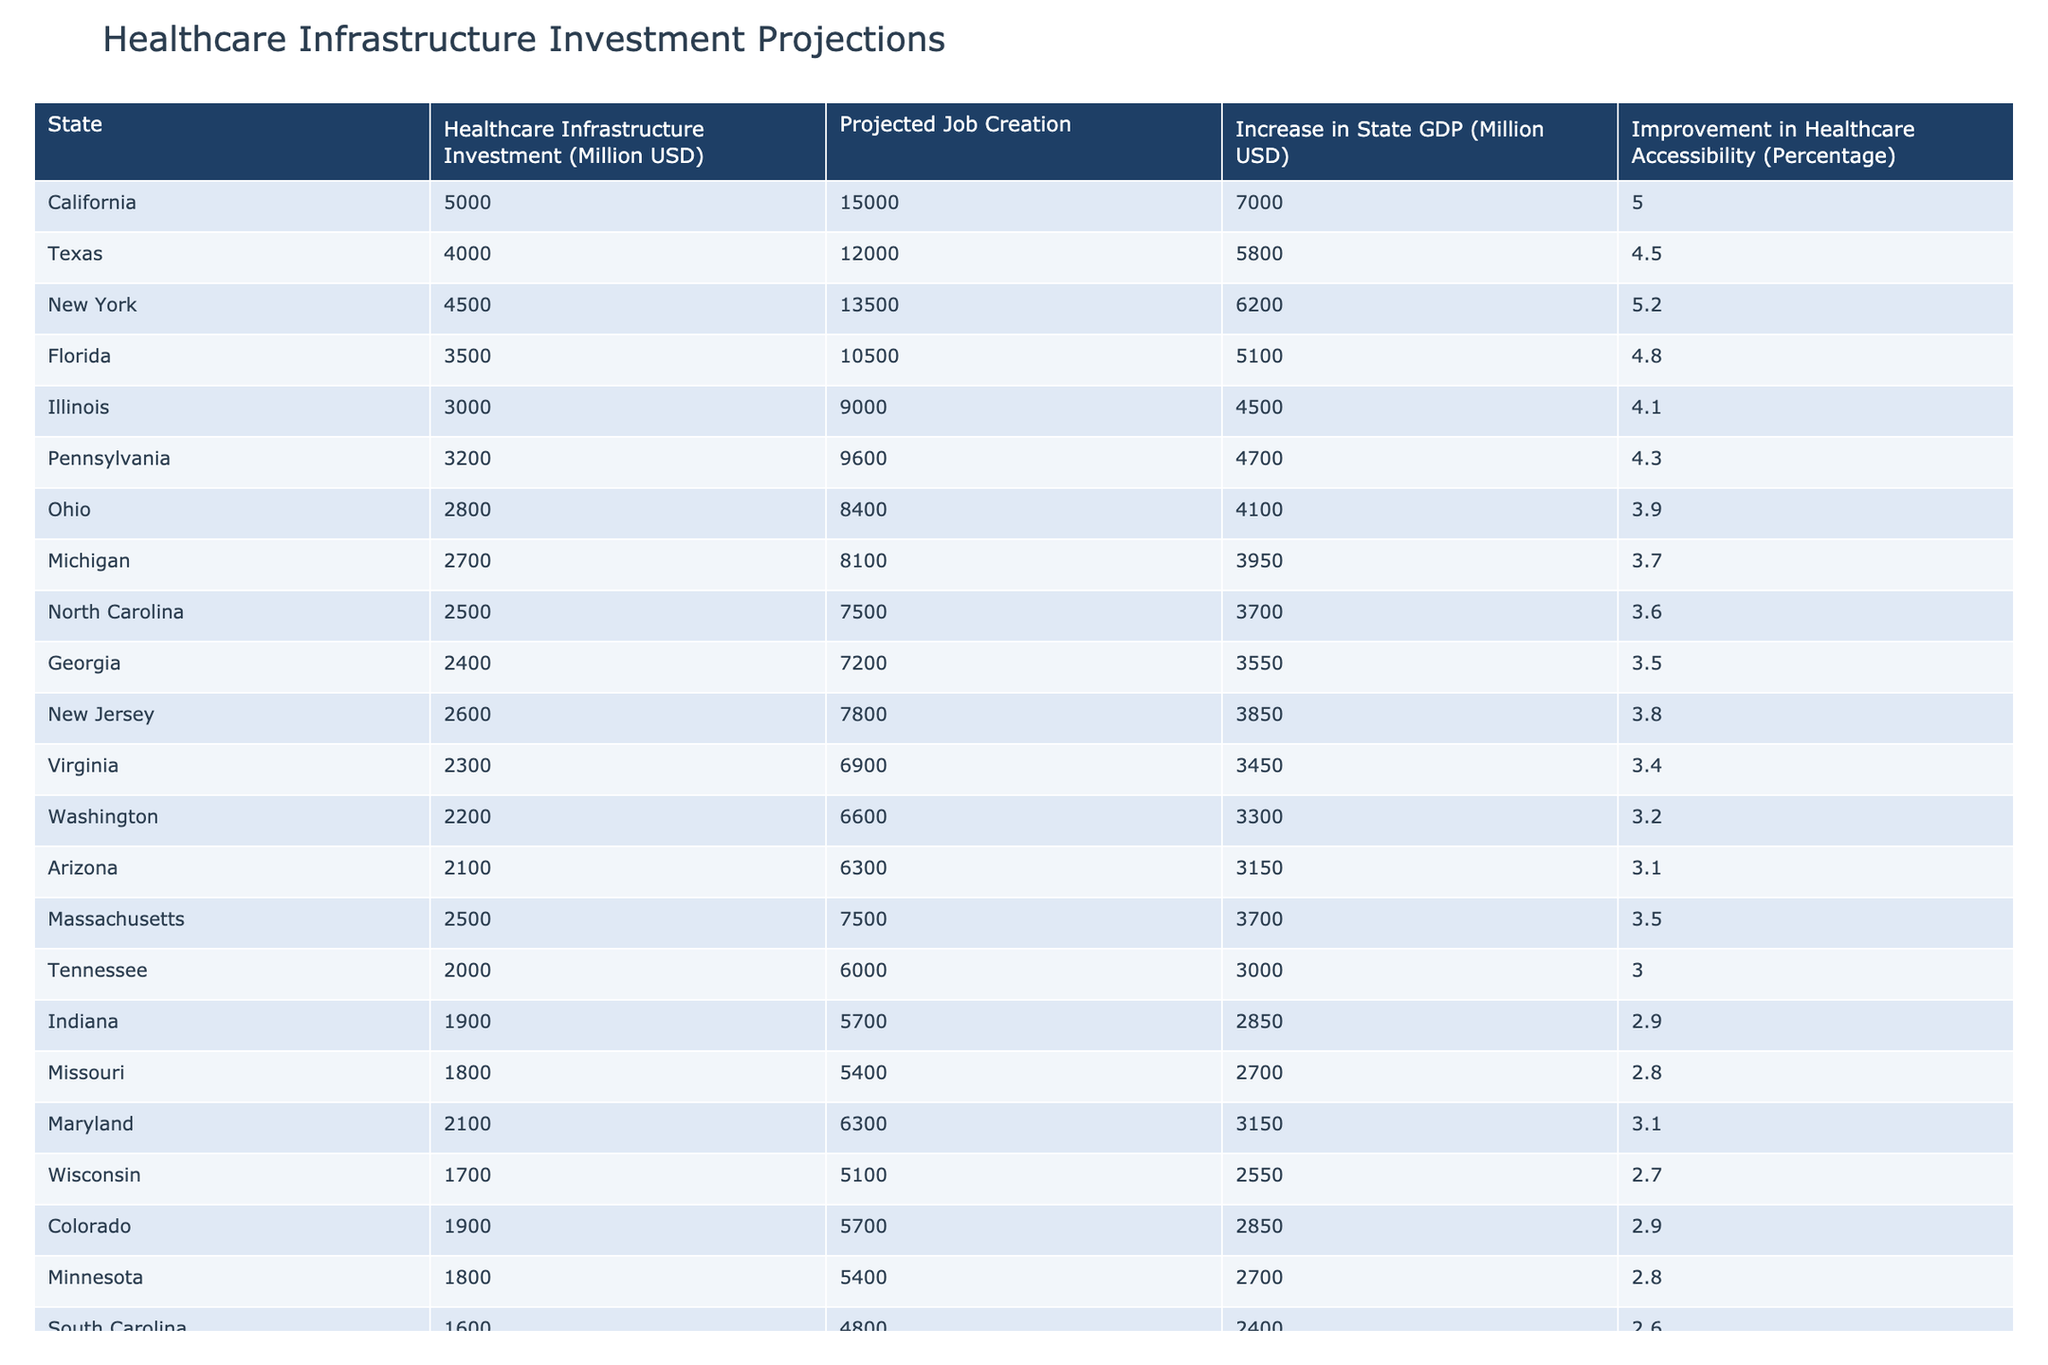What is the projected job creation for California? The value for projected job creation can be found directly under the "Projected Job Creation" column for California. It shows 15,000 jobs.
Answer: 15000 Which state has the highest increase in state GDP? By looking at the "Increase in State GDP" column, California shows the highest value at 7,000 million USD.
Answer: California What is the total healthcare infrastructure investment for Texas and Florida combined? To find the total, we need to add Texas's investment of 4,000 million USD to Florida's investment of 3,500 million USD: 4,000 + 3,500 = 7,500 million USD.
Answer: 7500 Is there an improvement in healthcare accessibility of 4.5% or higher for states other than California? We need to check the "Improvement in Healthcare Accessibility" column for states other than California. Texas (4.5%), New York (5.2%), and Florida (4.8%) show improvements of 4.5% or higher. Therefore, the answer is yes.
Answer: Yes What is the average projected job creation across all states listed in the table? First, we sum up all the projected job creation numbers: (15000 + 12000 + 13500 + 10500 + 9000 + 9600 + 8400 + 8100 + 7500 + 7200 + 7800 + 6900 + 6600 + 6300 + 7500 + 6000 + 5700 + 5400 + 6300 + 5100 + 5700 + 5400 + 4800 + 4500 + 4200) = 126300. Then, we divide by the number of states (25) to find the average: 126300 / 25 = 5052.
Answer: 5052 Which states have a healthcare infrastructure investment below 2,000 million USD? By inspecting the "Healthcare Infrastructure Investment" column, we note that the investments are only listed down to 1,400 million USD, which is for Louisiana. No states have investments below this amount.
Answer: No states 